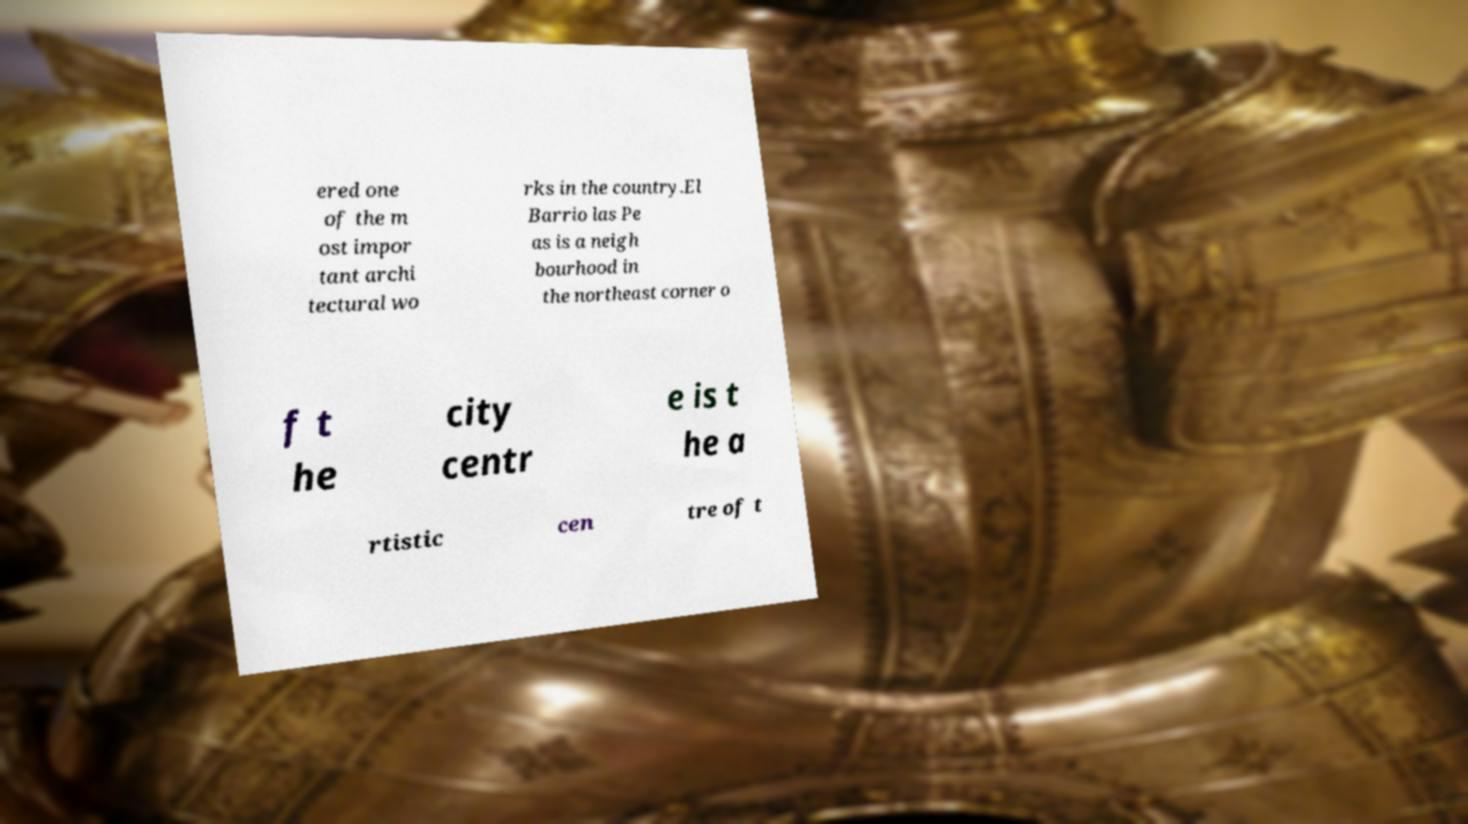There's text embedded in this image that I need extracted. Can you transcribe it verbatim? ered one of the m ost impor tant archi tectural wo rks in the country.El Barrio las Pe as is a neigh bourhood in the northeast corner o f t he city centr e is t he a rtistic cen tre of t 